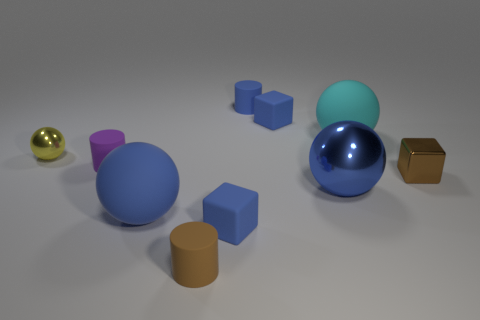What color is the tiny thing that is the same material as the tiny brown block?
Make the answer very short. Yellow. Is the shape of the purple object the same as the tiny blue matte object that is in front of the small purple object?
Your response must be concise. No. Are there any large cyan things to the left of the big cyan object?
Provide a short and direct response. No. What material is the small thing that is the same color as the small metal cube?
Make the answer very short. Rubber. There is a brown metal cube; does it have the same size as the matte ball that is in front of the purple thing?
Make the answer very short. No. Is there a rubber sphere of the same color as the metallic block?
Provide a succinct answer. No. Is there a blue rubber object that has the same shape as the yellow shiny object?
Keep it short and to the point. Yes. There is a blue rubber thing that is both in front of the tiny brown metallic object and right of the small brown matte object; what shape is it?
Make the answer very short. Cube. What number of other tiny brown cylinders are made of the same material as the brown cylinder?
Ensure brevity in your answer.  0. Are there fewer brown cylinders behind the brown block than small purple cylinders?
Give a very brief answer. Yes. 